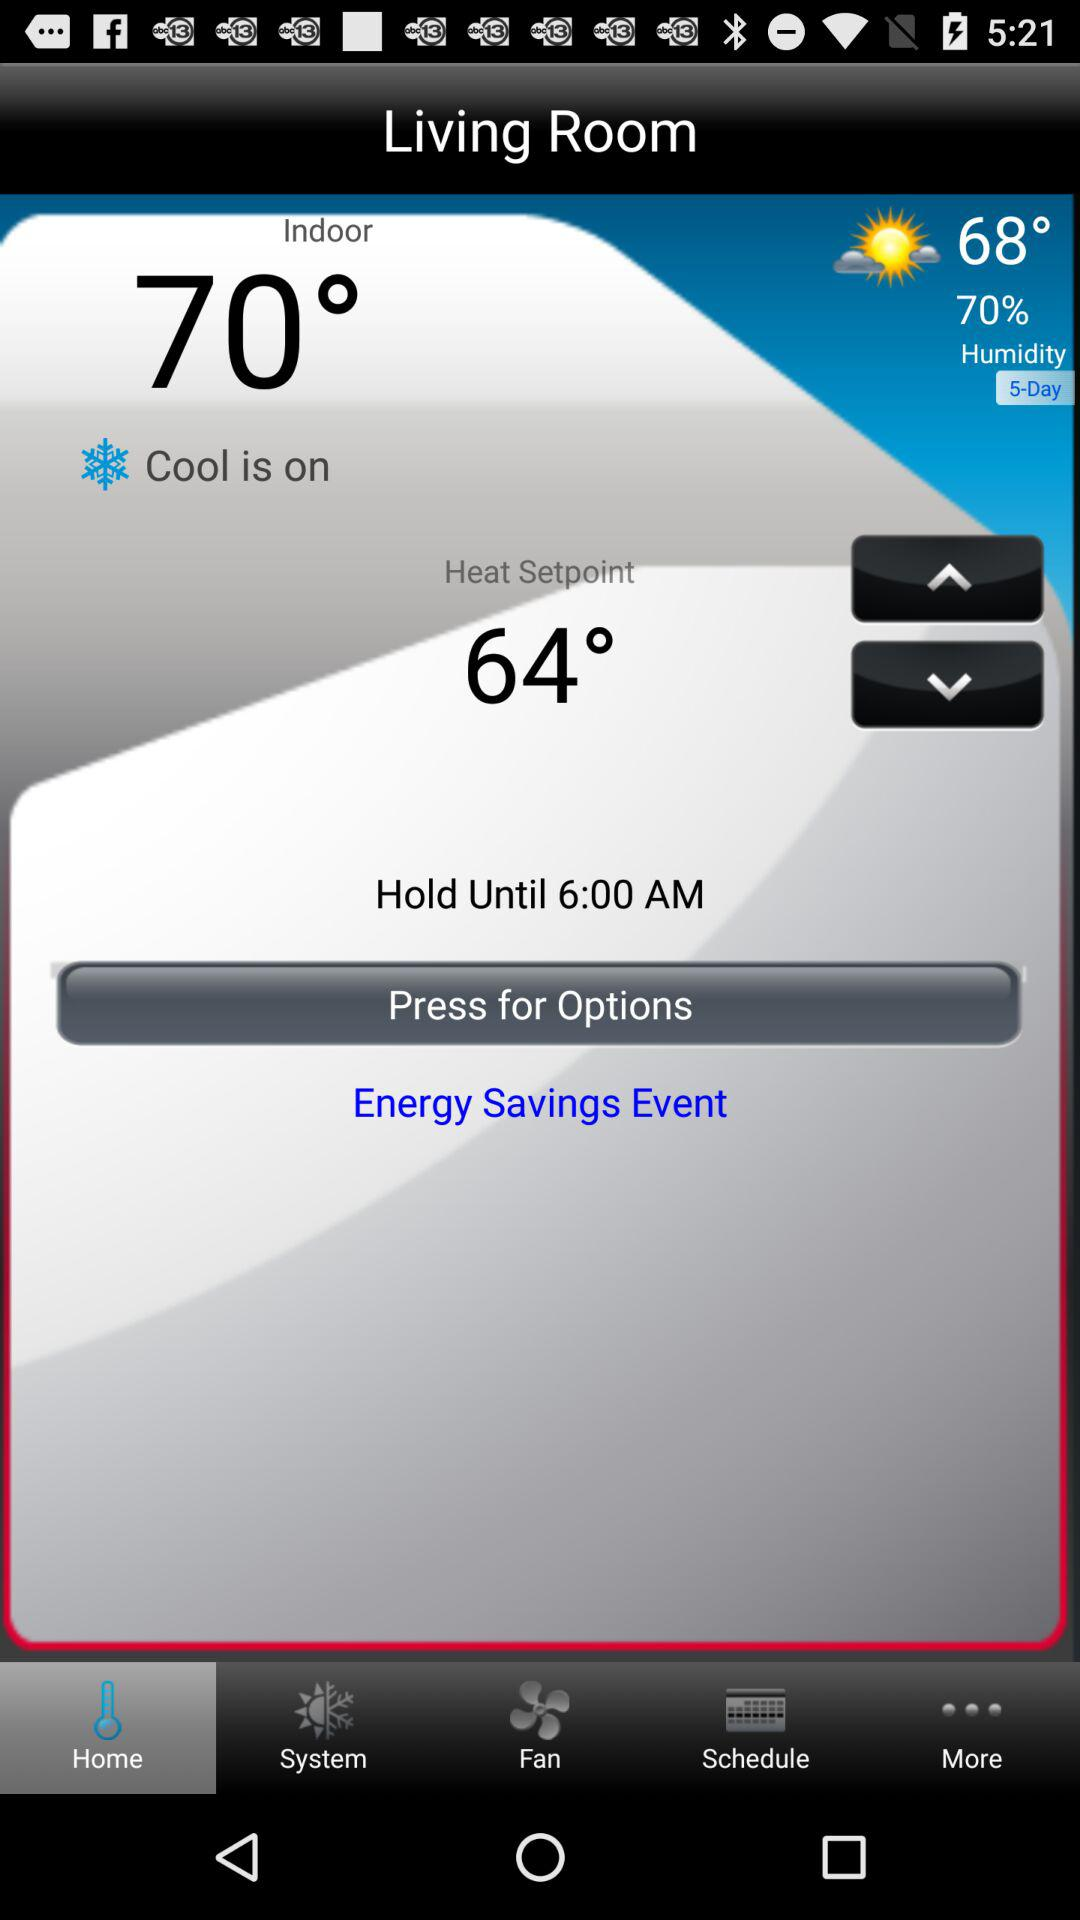Is cool on or off?
Answer the question using a single word or phrase. Cool is on. 